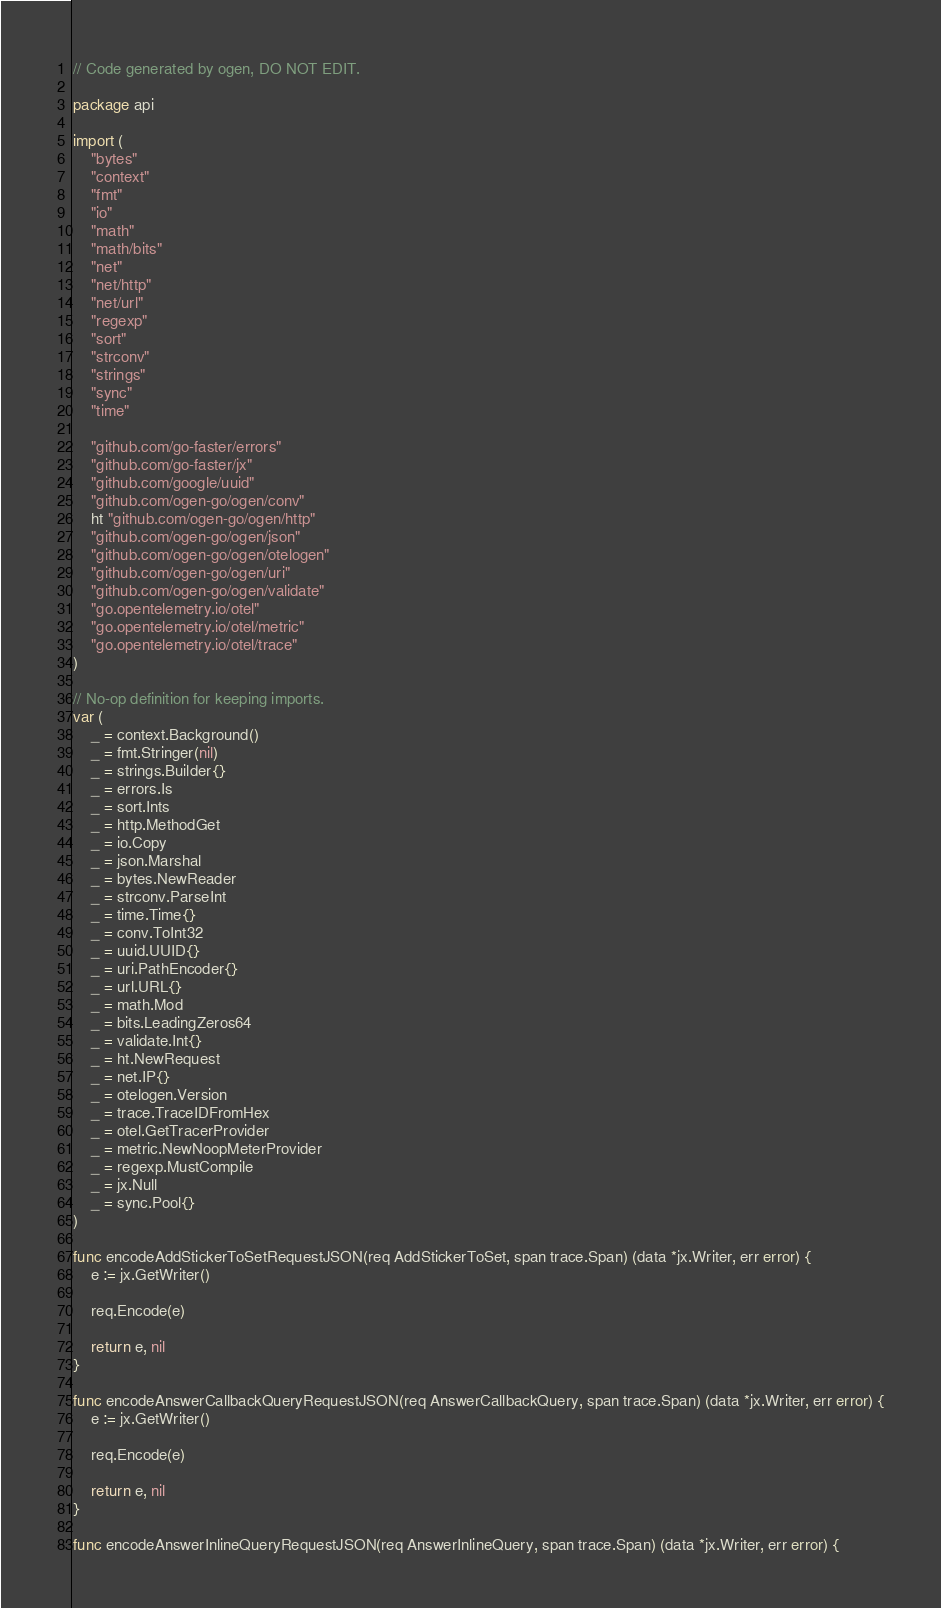<code> <loc_0><loc_0><loc_500><loc_500><_Go_>// Code generated by ogen, DO NOT EDIT.

package api

import (
	"bytes"
	"context"
	"fmt"
	"io"
	"math"
	"math/bits"
	"net"
	"net/http"
	"net/url"
	"regexp"
	"sort"
	"strconv"
	"strings"
	"sync"
	"time"

	"github.com/go-faster/errors"
	"github.com/go-faster/jx"
	"github.com/google/uuid"
	"github.com/ogen-go/ogen/conv"
	ht "github.com/ogen-go/ogen/http"
	"github.com/ogen-go/ogen/json"
	"github.com/ogen-go/ogen/otelogen"
	"github.com/ogen-go/ogen/uri"
	"github.com/ogen-go/ogen/validate"
	"go.opentelemetry.io/otel"
	"go.opentelemetry.io/otel/metric"
	"go.opentelemetry.io/otel/trace"
)

// No-op definition for keeping imports.
var (
	_ = context.Background()
	_ = fmt.Stringer(nil)
	_ = strings.Builder{}
	_ = errors.Is
	_ = sort.Ints
	_ = http.MethodGet
	_ = io.Copy
	_ = json.Marshal
	_ = bytes.NewReader
	_ = strconv.ParseInt
	_ = time.Time{}
	_ = conv.ToInt32
	_ = uuid.UUID{}
	_ = uri.PathEncoder{}
	_ = url.URL{}
	_ = math.Mod
	_ = bits.LeadingZeros64
	_ = validate.Int{}
	_ = ht.NewRequest
	_ = net.IP{}
	_ = otelogen.Version
	_ = trace.TraceIDFromHex
	_ = otel.GetTracerProvider
	_ = metric.NewNoopMeterProvider
	_ = regexp.MustCompile
	_ = jx.Null
	_ = sync.Pool{}
)

func encodeAddStickerToSetRequestJSON(req AddStickerToSet, span trace.Span) (data *jx.Writer, err error) {
	e := jx.GetWriter()

	req.Encode(e)

	return e, nil
}

func encodeAnswerCallbackQueryRequestJSON(req AnswerCallbackQuery, span trace.Span) (data *jx.Writer, err error) {
	e := jx.GetWriter()

	req.Encode(e)

	return e, nil
}

func encodeAnswerInlineQueryRequestJSON(req AnswerInlineQuery, span trace.Span) (data *jx.Writer, err error) {</code> 